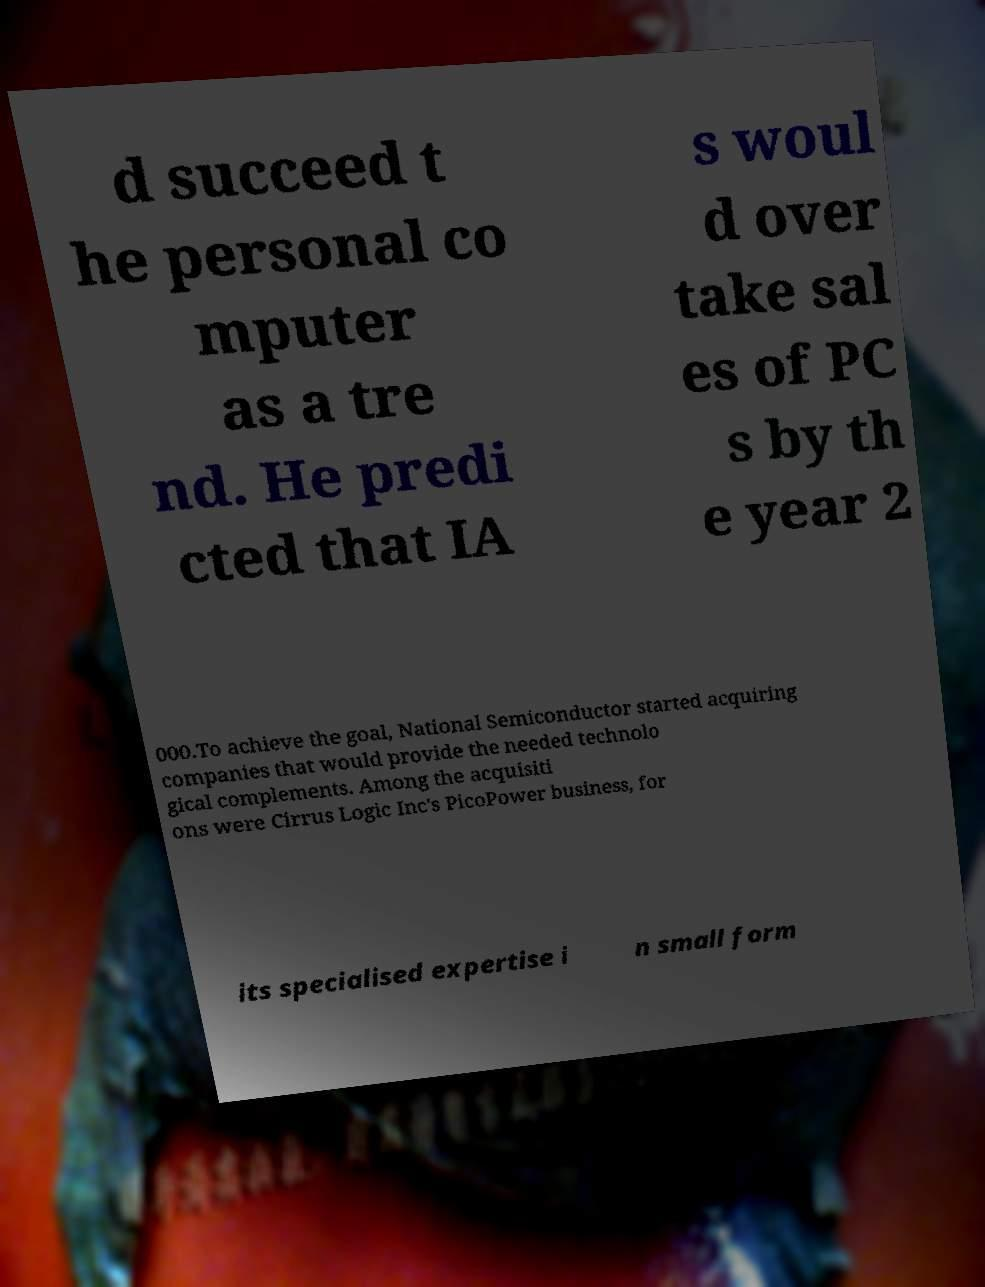Please identify and transcribe the text found in this image. d succeed t he personal co mputer as a tre nd. He predi cted that IA s woul d over take sal es of PC s by th e year 2 000.To achieve the goal, National Semiconductor started acquiring companies that would provide the needed technolo gical complements. Among the acquisiti ons were Cirrus Logic Inc's PicoPower business, for its specialised expertise i n small form 